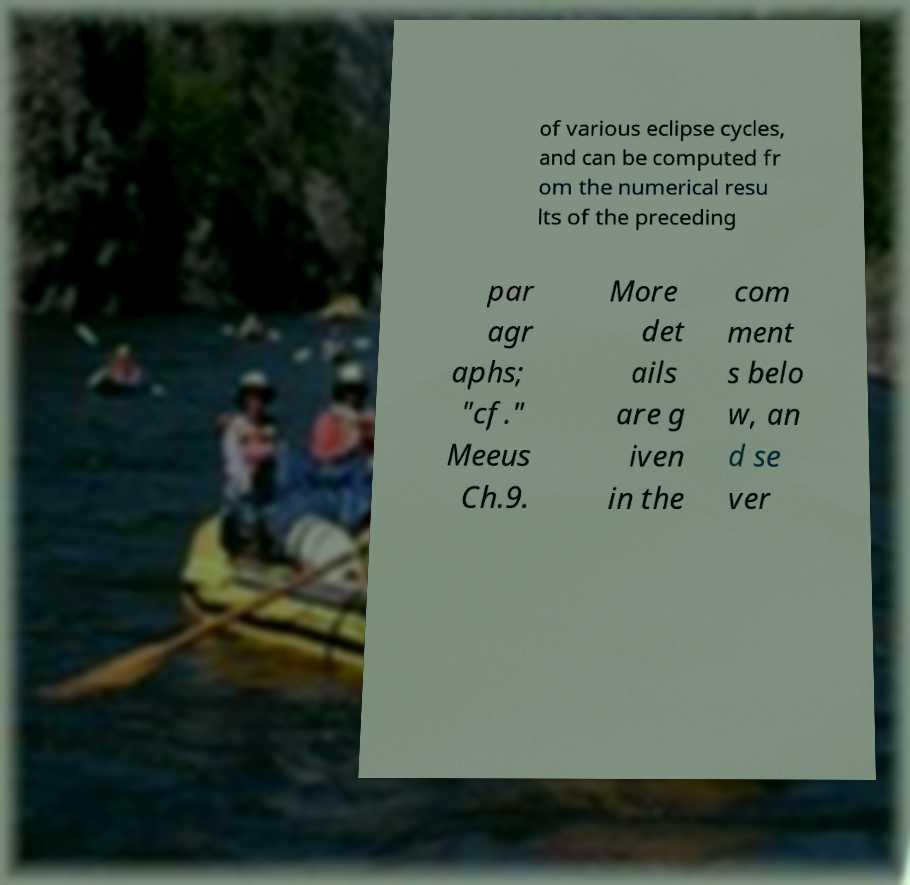For documentation purposes, I need the text within this image transcribed. Could you provide that? of various eclipse cycles, and can be computed fr om the numerical resu lts of the preceding par agr aphs; "cf." Meeus Ch.9. More det ails are g iven in the com ment s belo w, an d se ver 